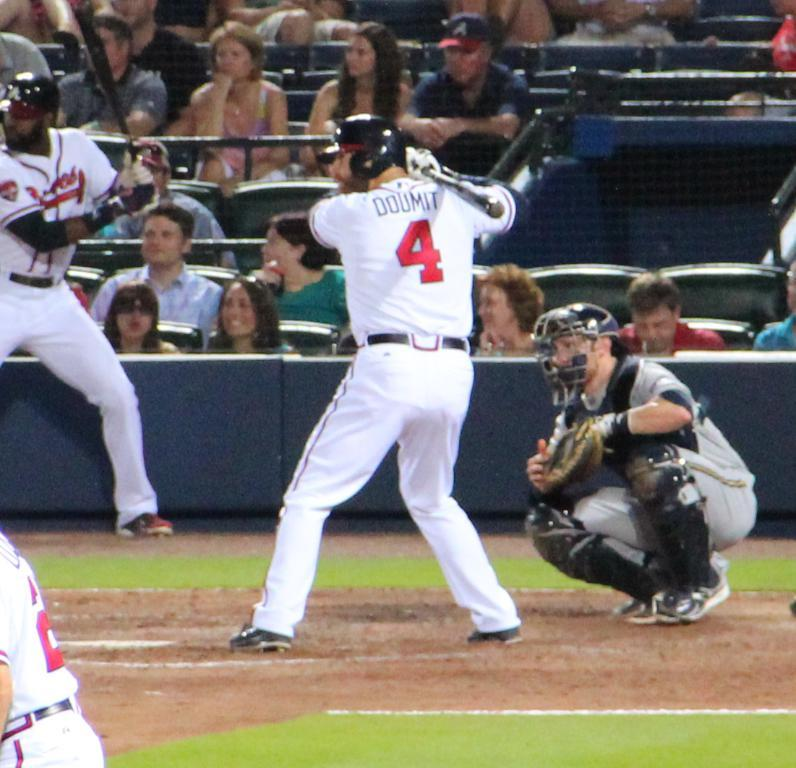<image>
Summarize the visual content of the image. Player number 4 is about to swing for the ball. 